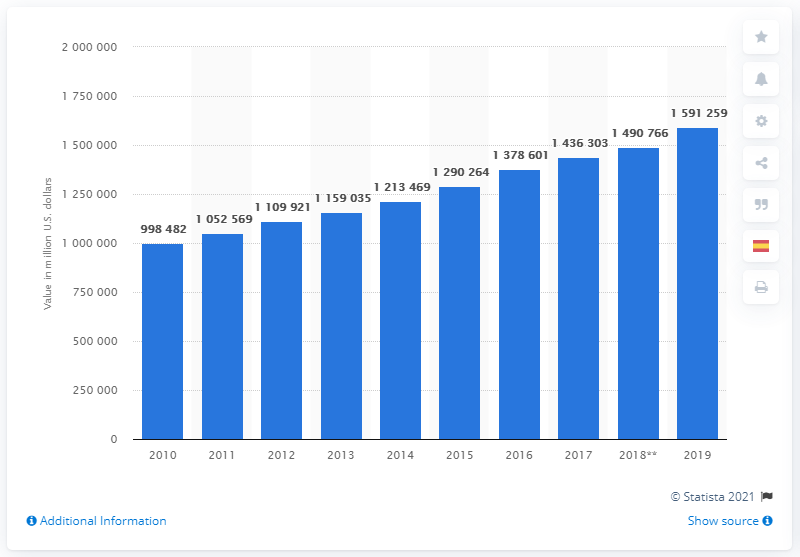Outline some significant characteristics in this image. The value of property, plant and equipment in service between 2010 and 2019 was 159,125,900. 